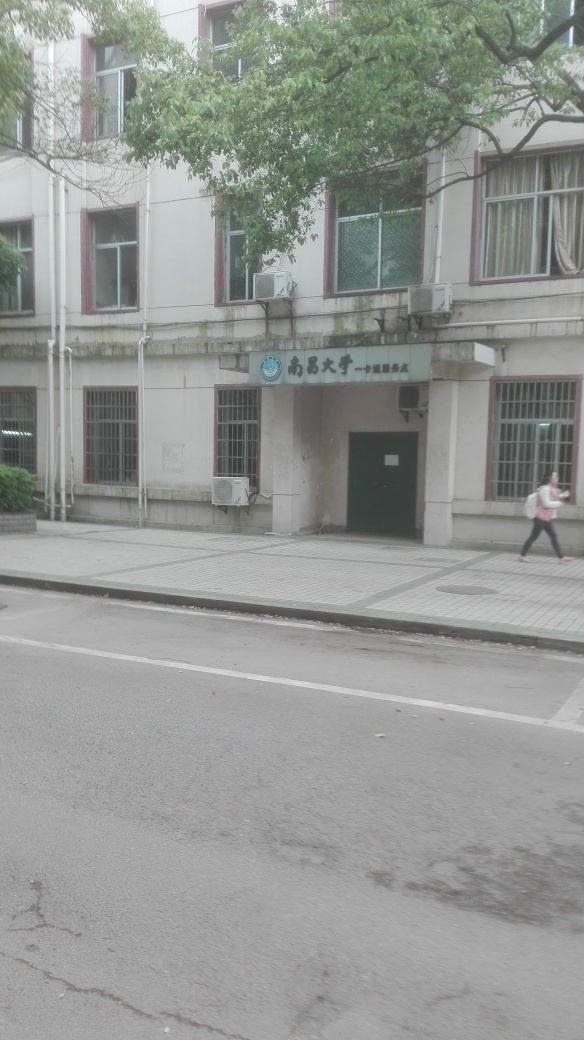Can you tell me about the architectural style of the building? The building features a relatively simple and functional architectural style, likely dating from the mid to late 20th century. It has a straightforward, utilitarian design, with symmetrically placed windows and minimal decorative elements. 